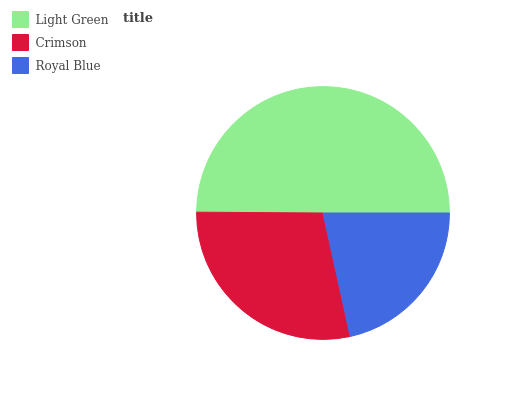Is Royal Blue the minimum?
Answer yes or no. Yes. Is Light Green the maximum?
Answer yes or no. Yes. Is Crimson the minimum?
Answer yes or no. No. Is Crimson the maximum?
Answer yes or no. No. Is Light Green greater than Crimson?
Answer yes or no. Yes. Is Crimson less than Light Green?
Answer yes or no. Yes. Is Crimson greater than Light Green?
Answer yes or no. No. Is Light Green less than Crimson?
Answer yes or no. No. Is Crimson the high median?
Answer yes or no. Yes. Is Crimson the low median?
Answer yes or no. Yes. Is Royal Blue the high median?
Answer yes or no. No. Is Royal Blue the low median?
Answer yes or no. No. 